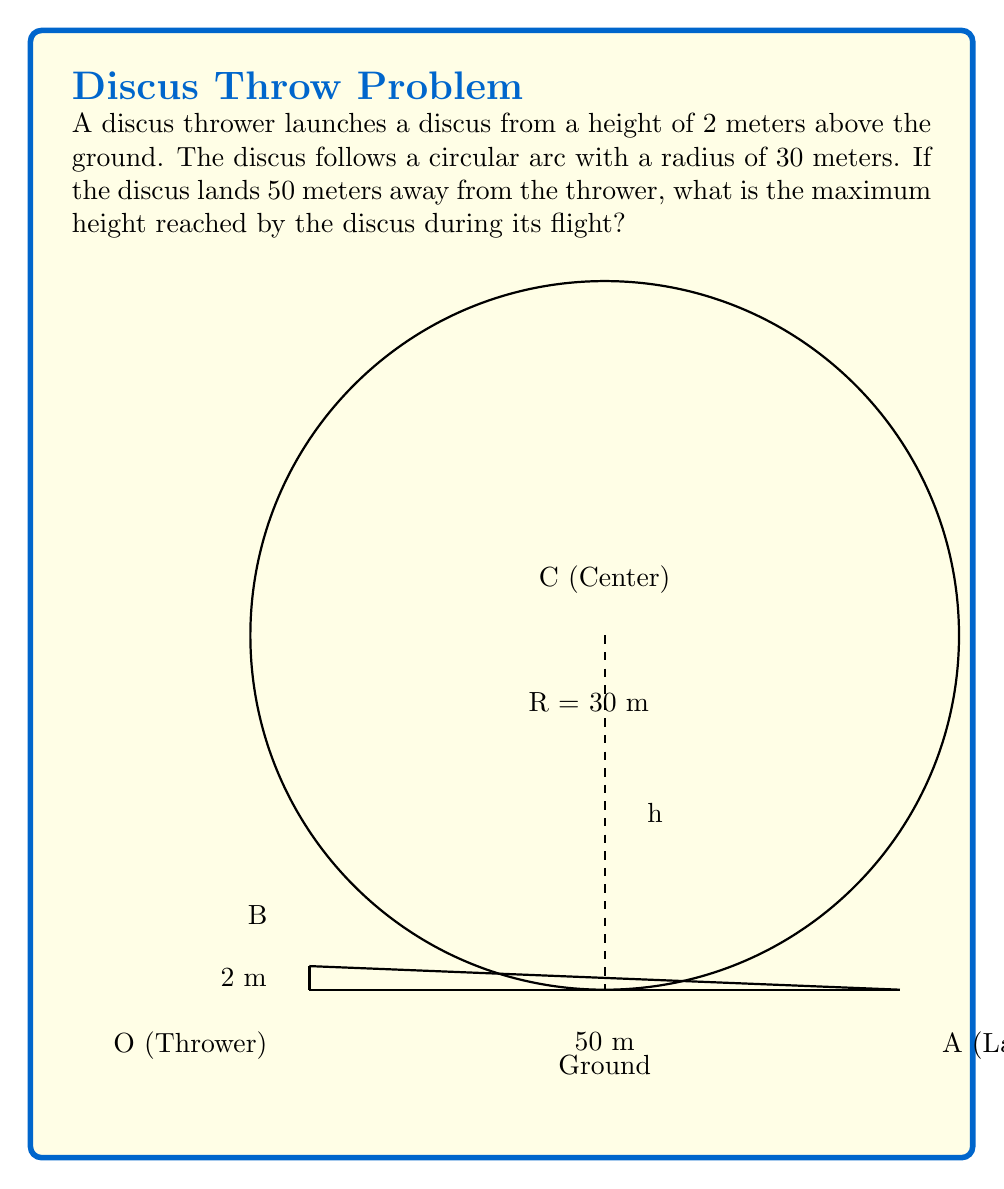Can you solve this math problem? Let's approach this step-by-step:

1) The circular arc of the discus throw forms part of a circle. We know:
   - The radius of the circle (R) = 30 meters
   - The horizontal distance of the throw = 50 meters
   - The initial height = 2 meters

2) Let's set up a coordinate system with the thrower at (0,2) and the landing point at (50,0).

3) The center of the circle will be on the y-axis. Let's call its coordinates (0,y).

4) We can form a right triangle with:
   - Hypotenuse = radius = 30 m
   - Base = half of the horizontal distance = 25 m
   - Height = y - 2 (distance from center to initial height)

5) Using the Pythagorean theorem:

   $$(25)^2 + (y-2)^2 = 30^2$$

6) Simplify:
   $$625 + y^2 - 4y + 4 = 900$$
   $$y^2 - 4y - 271 = 0$$

7) This is a quadratic equation. We can solve it using the quadratic formula:
   $$y = \frac{4 \pm \sqrt{4^2 + 4(1)(271)}}{2(1)}$$
   $$y = \frac{4 \pm \sqrt{1100}}{2}$$
   $$y = 2 \pm \sqrt{275}$$

8) We want the positive solution:
   $$y = 2 + \sqrt{275} \approx 18.58$$

9) The maximum height of the discus is this y-value:
   $$h_{max} = 18.58$$

Therefore, the maximum height reached by the discus is approximately 18.58 meters.
Answer: 18.58 meters 